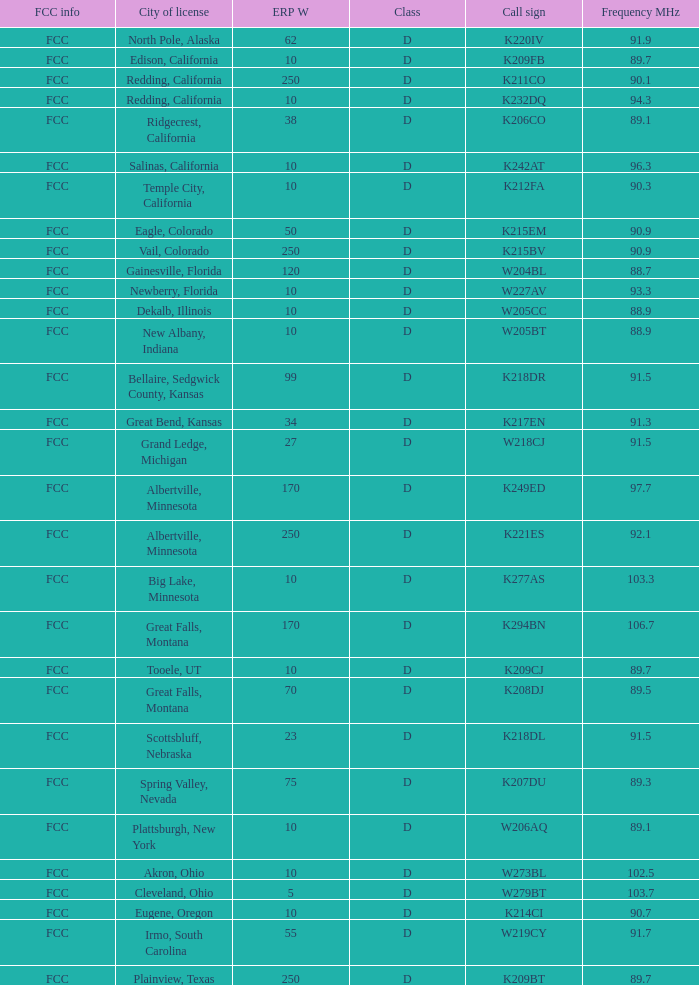Write the full table. {'header': ['FCC info', 'City of license', 'ERP W', 'Class', 'Call sign', 'Frequency MHz'], 'rows': [['FCC', 'North Pole, Alaska', '62', 'D', 'K220IV', '91.9'], ['FCC', 'Edison, California', '10', 'D', 'K209FB', '89.7'], ['FCC', 'Redding, California', '250', 'D', 'K211CO', '90.1'], ['FCC', 'Redding, California', '10', 'D', 'K232DQ', '94.3'], ['FCC', 'Ridgecrest, California', '38', 'D', 'K206CO', '89.1'], ['FCC', 'Salinas, California', '10', 'D', 'K242AT', '96.3'], ['FCC', 'Temple City, California', '10', 'D', 'K212FA', '90.3'], ['FCC', 'Eagle, Colorado', '50', 'D', 'K215EM', '90.9'], ['FCC', 'Vail, Colorado', '250', 'D', 'K215BV', '90.9'], ['FCC', 'Gainesville, Florida', '120', 'D', 'W204BL', '88.7'], ['FCC', 'Newberry, Florida', '10', 'D', 'W227AV', '93.3'], ['FCC', 'Dekalb, Illinois', '10', 'D', 'W205CC', '88.9'], ['FCC', 'New Albany, Indiana', '10', 'D', 'W205BT', '88.9'], ['FCC', 'Bellaire, Sedgwick County, Kansas', '99', 'D', 'K218DR', '91.5'], ['FCC', 'Great Bend, Kansas', '34', 'D', 'K217EN', '91.3'], ['FCC', 'Grand Ledge, Michigan', '27', 'D', 'W218CJ', '91.5'], ['FCC', 'Albertville, Minnesota', '170', 'D', 'K249ED', '97.7'], ['FCC', 'Albertville, Minnesota', '250', 'D', 'K221ES', '92.1'], ['FCC', 'Big Lake, Minnesota', '10', 'D', 'K277AS', '103.3'], ['FCC', 'Great Falls, Montana', '170', 'D', 'K294BN', '106.7'], ['FCC', 'Tooele, UT', '10', 'D', 'K209CJ', '89.7'], ['FCC', 'Great Falls, Montana', '70', 'D', 'K208DJ', '89.5'], ['FCC', 'Scottsbluff, Nebraska', '23', 'D', 'K218DL', '91.5'], ['FCC', 'Spring Valley, Nevada', '75', 'D', 'K207DU', '89.3'], ['FCC', 'Plattsburgh, New York', '10', 'D', 'W206AQ', '89.1'], ['FCC', 'Akron, Ohio', '10', 'D', 'W273BL', '102.5'], ['FCC', 'Cleveland, Ohio', '5', 'D', 'W279BT', '103.7'], ['FCC', 'Eugene, Oregon', '10', 'D', 'K214CI', '90.7'], ['FCC', 'Irmo, South Carolina', '55', 'D', 'W219CY', '91.7'], ['FCC', 'Plainview, Texas', '250', 'D', 'K209BT', '89.7']]} What is the call sign of the translator with an ERP W greater than 38 and a city license from Great Falls, Montana? K294BN, K208DJ. 